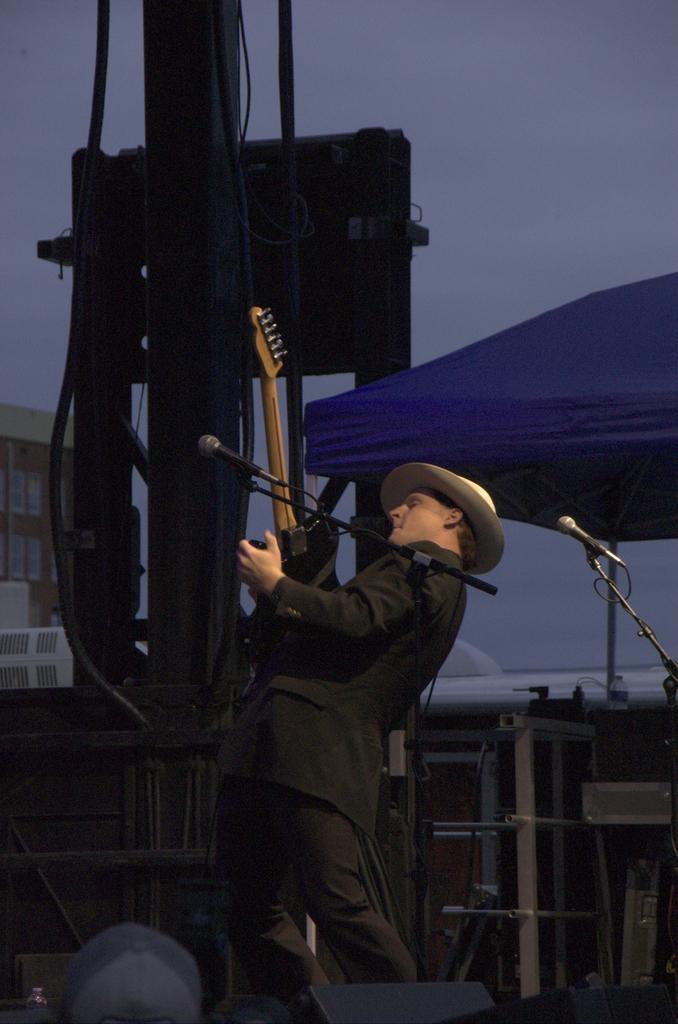Describe this image in one or two sentences. In this image we can see a man is standing and playing guitar. He is wearing a suit and a hat. In front of him, we can see a mic and stand. At the bottom of the image, we can see some objects. In the background, we can see buildings, umbrella, pole and metal objects. At the top of the image, we can see the sky. There is one more mic on the right side of the image. 